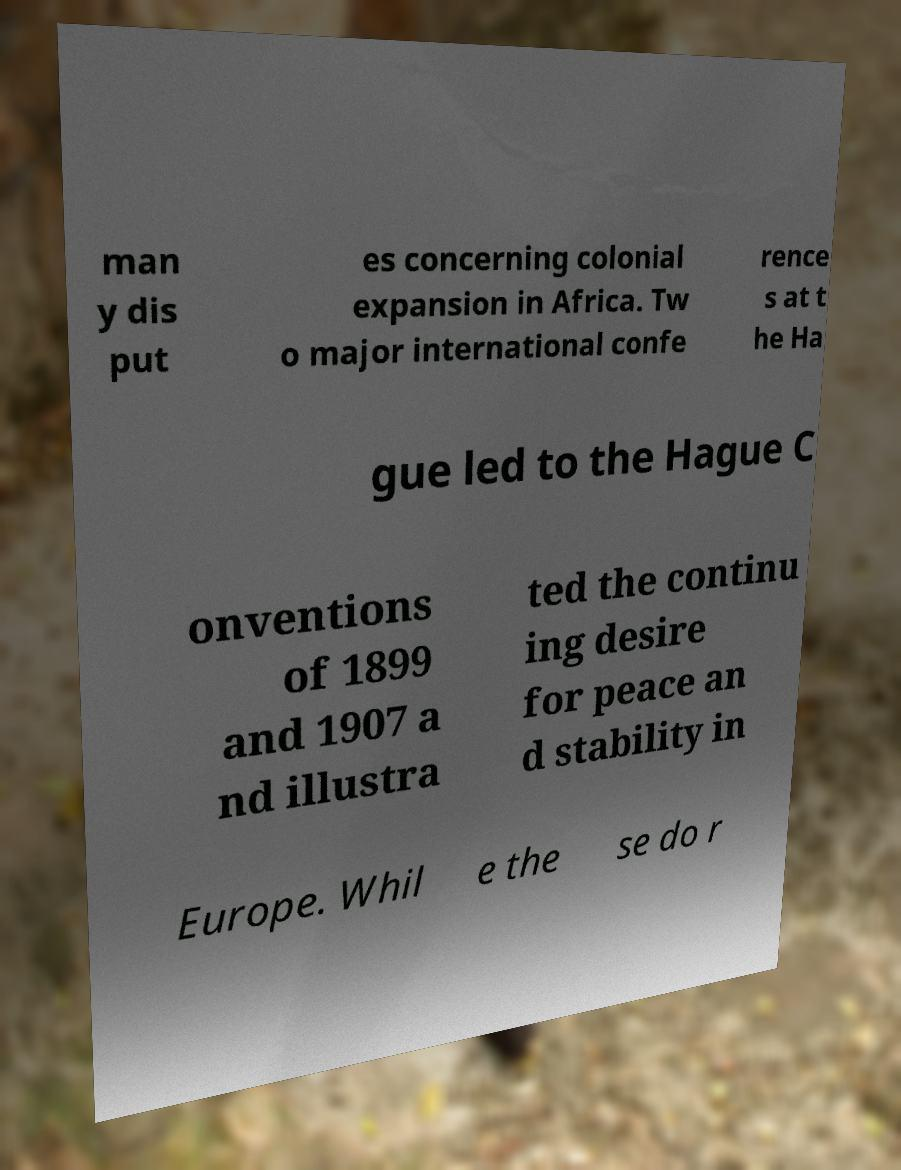Could you assist in decoding the text presented in this image and type it out clearly? man y dis put es concerning colonial expansion in Africa. Tw o major international confe rence s at t he Ha gue led to the Hague C onventions of 1899 and 1907 a nd illustra ted the continu ing desire for peace an d stability in Europe. Whil e the se do r 